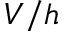Convert formula to latex. <formula><loc_0><loc_0><loc_500><loc_500>V / h</formula> 